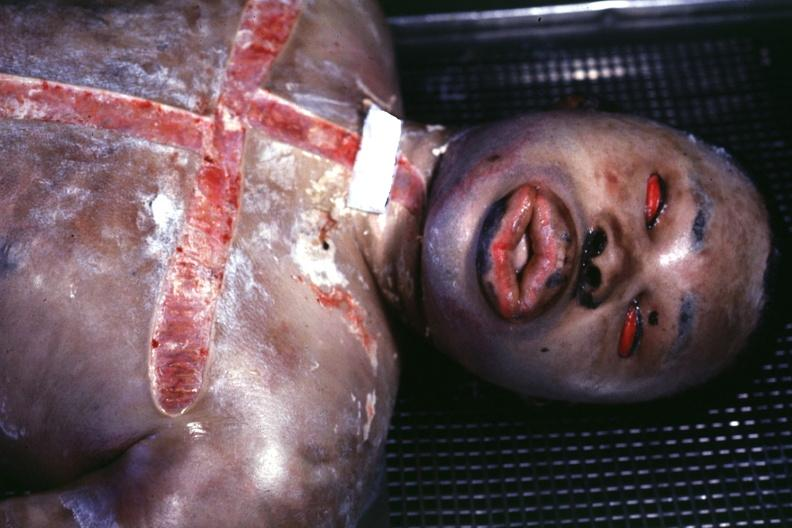does this image show burn case with view of face showing grotesque edema?
Answer the question using a single word or phrase. Yes 